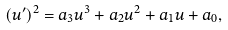<formula> <loc_0><loc_0><loc_500><loc_500>( u ^ { \prime } ) ^ { 2 } = a _ { 3 } u ^ { 3 } + a _ { 2 } u ^ { 2 } + a _ { 1 } u + a _ { 0 } ,</formula> 